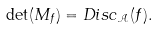Convert formula to latex. <formula><loc_0><loc_0><loc_500><loc_500>\det ( M _ { f } ) = D i s c _ { \mathcal { A } } ( f ) .</formula> 